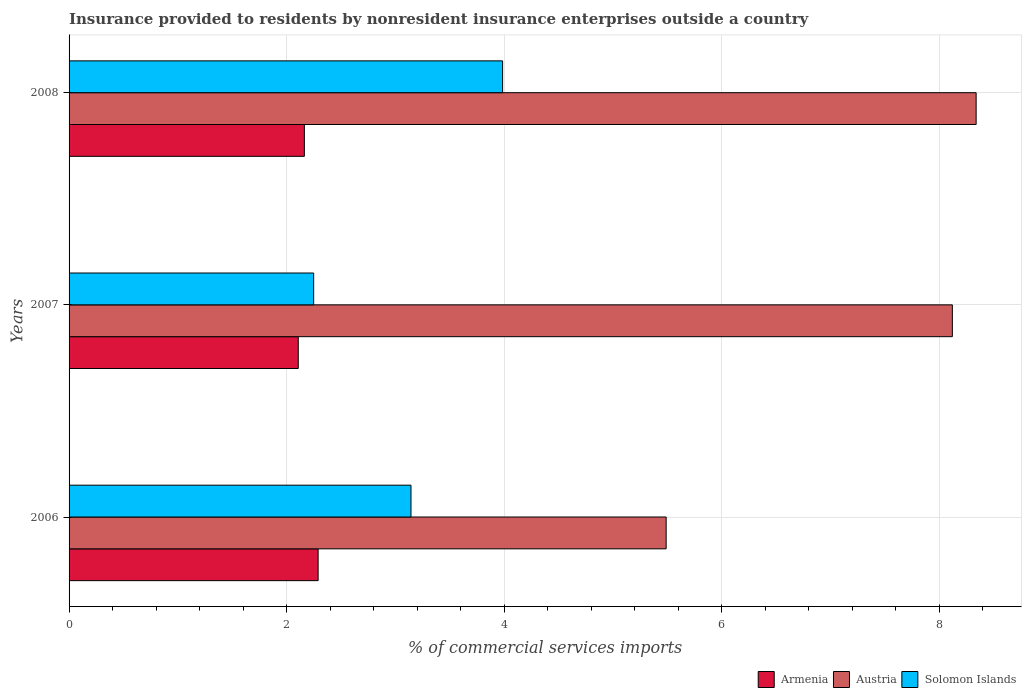Are the number of bars per tick equal to the number of legend labels?
Give a very brief answer. Yes. How many bars are there on the 1st tick from the top?
Give a very brief answer. 3. What is the label of the 3rd group of bars from the top?
Your answer should be very brief. 2006. What is the Insurance provided to residents in Austria in 2007?
Provide a succinct answer. 8.12. Across all years, what is the maximum Insurance provided to residents in Austria?
Your answer should be very brief. 8.34. Across all years, what is the minimum Insurance provided to residents in Solomon Islands?
Give a very brief answer. 2.25. In which year was the Insurance provided to residents in Solomon Islands maximum?
Your response must be concise. 2008. In which year was the Insurance provided to residents in Austria minimum?
Your answer should be very brief. 2006. What is the total Insurance provided to residents in Armenia in the graph?
Provide a succinct answer. 6.56. What is the difference between the Insurance provided to residents in Austria in 2007 and that in 2008?
Your response must be concise. -0.22. What is the difference between the Insurance provided to residents in Austria in 2006 and the Insurance provided to residents in Armenia in 2008?
Your answer should be compact. 3.33. What is the average Insurance provided to residents in Solomon Islands per year?
Make the answer very short. 3.13. In the year 2008, what is the difference between the Insurance provided to residents in Austria and Insurance provided to residents in Solomon Islands?
Offer a very short reply. 4.35. What is the ratio of the Insurance provided to residents in Armenia in 2007 to that in 2008?
Offer a very short reply. 0.97. Is the Insurance provided to residents in Austria in 2007 less than that in 2008?
Ensure brevity in your answer.  Yes. Is the difference between the Insurance provided to residents in Austria in 2006 and 2007 greater than the difference between the Insurance provided to residents in Solomon Islands in 2006 and 2007?
Your response must be concise. No. What is the difference between the highest and the second highest Insurance provided to residents in Solomon Islands?
Provide a succinct answer. 0.84. What is the difference between the highest and the lowest Insurance provided to residents in Austria?
Ensure brevity in your answer.  2.85. In how many years, is the Insurance provided to residents in Solomon Islands greater than the average Insurance provided to residents in Solomon Islands taken over all years?
Keep it short and to the point. 2. Is the sum of the Insurance provided to residents in Solomon Islands in 2006 and 2007 greater than the maximum Insurance provided to residents in Austria across all years?
Ensure brevity in your answer.  No. What does the 3rd bar from the top in 2006 represents?
Your answer should be compact. Armenia. What does the 1st bar from the bottom in 2008 represents?
Offer a very short reply. Armenia. Is it the case that in every year, the sum of the Insurance provided to residents in Armenia and Insurance provided to residents in Solomon Islands is greater than the Insurance provided to residents in Austria?
Give a very brief answer. No. How many bars are there?
Offer a terse response. 9. Are all the bars in the graph horizontal?
Provide a short and direct response. Yes. How many years are there in the graph?
Keep it short and to the point. 3. What is the difference between two consecutive major ticks on the X-axis?
Provide a succinct answer. 2. Does the graph contain grids?
Keep it short and to the point. Yes. Where does the legend appear in the graph?
Your answer should be very brief. Bottom right. What is the title of the graph?
Provide a succinct answer. Insurance provided to residents by nonresident insurance enterprises outside a country. What is the label or title of the X-axis?
Offer a terse response. % of commercial services imports. What is the label or title of the Y-axis?
Your answer should be very brief. Years. What is the % of commercial services imports of Armenia in 2006?
Make the answer very short. 2.29. What is the % of commercial services imports in Austria in 2006?
Keep it short and to the point. 5.49. What is the % of commercial services imports of Solomon Islands in 2006?
Your answer should be very brief. 3.14. What is the % of commercial services imports in Armenia in 2007?
Offer a terse response. 2.11. What is the % of commercial services imports of Austria in 2007?
Your answer should be compact. 8.12. What is the % of commercial services imports in Solomon Islands in 2007?
Give a very brief answer. 2.25. What is the % of commercial services imports of Armenia in 2008?
Make the answer very short. 2.16. What is the % of commercial services imports in Austria in 2008?
Provide a short and direct response. 8.34. What is the % of commercial services imports in Solomon Islands in 2008?
Give a very brief answer. 3.99. Across all years, what is the maximum % of commercial services imports in Armenia?
Your response must be concise. 2.29. Across all years, what is the maximum % of commercial services imports in Austria?
Your response must be concise. 8.34. Across all years, what is the maximum % of commercial services imports of Solomon Islands?
Your response must be concise. 3.99. Across all years, what is the minimum % of commercial services imports in Armenia?
Offer a terse response. 2.11. Across all years, what is the minimum % of commercial services imports in Austria?
Keep it short and to the point. 5.49. Across all years, what is the minimum % of commercial services imports of Solomon Islands?
Your response must be concise. 2.25. What is the total % of commercial services imports in Armenia in the graph?
Offer a terse response. 6.56. What is the total % of commercial services imports of Austria in the graph?
Give a very brief answer. 21.95. What is the total % of commercial services imports of Solomon Islands in the graph?
Offer a very short reply. 9.38. What is the difference between the % of commercial services imports of Armenia in 2006 and that in 2007?
Keep it short and to the point. 0.18. What is the difference between the % of commercial services imports in Austria in 2006 and that in 2007?
Make the answer very short. -2.63. What is the difference between the % of commercial services imports in Solomon Islands in 2006 and that in 2007?
Your response must be concise. 0.89. What is the difference between the % of commercial services imports of Armenia in 2006 and that in 2008?
Provide a succinct answer. 0.13. What is the difference between the % of commercial services imports of Austria in 2006 and that in 2008?
Provide a succinct answer. -2.85. What is the difference between the % of commercial services imports of Solomon Islands in 2006 and that in 2008?
Provide a succinct answer. -0.84. What is the difference between the % of commercial services imports of Armenia in 2007 and that in 2008?
Keep it short and to the point. -0.06. What is the difference between the % of commercial services imports of Austria in 2007 and that in 2008?
Your response must be concise. -0.22. What is the difference between the % of commercial services imports of Solomon Islands in 2007 and that in 2008?
Provide a succinct answer. -1.74. What is the difference between the % of commercial services imports of Armenia in 2006 and the % of commercial services imports of Austria in 2007?
Ensure brevity in your answer.  -5.83. What is the difference between the % of commercial services imports of Armenia in 2006 and the % of commercial services imports of Solomon Islands in 2007?
Offer a very short reply. 0.04. What is the difference between the % of commercial services imports of Austria in 2006 and the % of commercial services imports of Solomon Islands in 2007?
Give a very brief answer. 3.24. What is the difference between the % of commercial services imports of Armenia in 2006 and the % of commercial services imports of Austria in 2008?
Make the answer very short. -6.05. What is the difference between the % of commercial services imports of Armenia in 2006 and the % of commercial services imports of Solomon Islands in 2008?
Provide a short and direct response. -1.7. What is the difference between the % of commercial services imports of Austria in 2006 and the % of commercial services imports of Solomon Islands in 2008?
Your answer should be compact. 1.5. What is the difference between the % of commercial services imports of Armenia in 2007 and the % of commercial services imports of Austria in 2008?
Keep it short and to the point. -6.23. What is the difference between the % of commercial services imports in Armenia in 2007 and the % of commercial services imports in Solomon Islands in 2008?
Provide a short and direct response. -1.88. What is the difference between the % of commercial services imports of Austria in 2007 and the % of commercial services imports of Solomon Islands in 2008?
Provide a short and direct response. 4.14. What is the average % of commercial services imports of Armenia per year?
Your answer should be compact. 2.19. What is the average % of commercial services imports of Austria per year?
Offer a terse response. 7.32. What is the average % of commercial services imports of Solomon Islands per year?
Offer a terse response. 3.13. In the year 2006, what is the difference between the % of commercial services imports in Armenia and % of commercial services imports in Austria?
Your answer should be compact. -3.2. In the year 2006, what is the difference between the % of commercial services imports of Armenia and % of commercial services imports of Solomon Islands?
Your response must be concise. -0.85. In the year 2006, what is the difference between the % of commercial services imports of Austria and % of commercial services imports of Solomon Islands?
Provide a succinct answer. 2.35. In the year 2007, what is the difference between the % of commercial services imports in Armenia and % of commercial services imports in Austria?
Your answer should be very brief. -6.01. In the year 2007, what is the difference between the % of commercial services imports of Armenia and % of commercial services imports of Solomon Islands?
Make the answer very short. -0.14. In the year 2007, what is the difference between the % of commercial services imports of Austria and % of commercial services imports of Solomon Islands?
Your answer should be compact. 5.87. In the year 2008, what is the difference between the % of commercial services imports of Armenia and % of commercial services imports of Austria?
Offer a very short reply. -6.18. In the year 2008, what is the difference between the % of commercial services imports in Armenia and % of commercial services imports in Solomon Islands?
Keep it short and to the point. -1.82. In the year 2008, what is the difference between the % of commercial services imports of Austria and % of commercial services imports of Solomon Islands?
Your answer should be very brief. 4.35. What is the ratio of the % of commercial services imports in Armenia in 2006 to that in 2007?
Your response must be concise. 1.09. What is the ratio of the % of commercial services imports in Austria in 2006 to that in 2007?
Keep it short and to the point. 0.68. What is the ratio of the % of commercial services imports in Solomon Islands in 2006 to that in 2007?
Your answer should be compact. 1.4. What is the ratio of the % of commercial services imports of Armenia in 2006 to that in 2008?
Your response must be concise. 1.06. What is the ratio of the % of commercial services imports of Austria in 2006 to that in 2008?
Provide a short and direct response. 0.66. What is the ratio of the % of commercial services imports in Solomon Islands in 2006 to that in 2008?
Ensure brevity in your answer.  0.79. What is the ratio of the % of commercial services imports in Armenia in 2007 to that in 2008?
Ensure brevity in your answer.  0.97. What is the ratio of the % of commercial services imports of Austria in 2007 to that in 2008?
Provide a succinct answer. 0.97. What is the ratio of the % of commercial services imports of Solomon Islands in 2007 to that in 2008?
Your answer should be compact. 0.56. What is the difference between the highest and the second highest % of commercial services imports of Armenia?
Ensure brevity in your answer.  0.13. What is the difference between the highest and the second highest % of commercial services imports of Austria?
Offer a very short reply. 0.22. What is the difference between the highest and the second highest % of commercial services imports of Solomon Islands?
Your answer should be very brief. 0.84. What is the difference between the highest and the lowest % of commercial services imports of Armenia?
Your answer should be very brief. 0.18. What is the difference between the highest and the lowest % of commercial services imports of Austria?
Your response must be concise. 2.85. What is the difference between the highest and the lowest % of commercial services imports of Solomon Islands?
Your answer should be very brief. 1.74. 